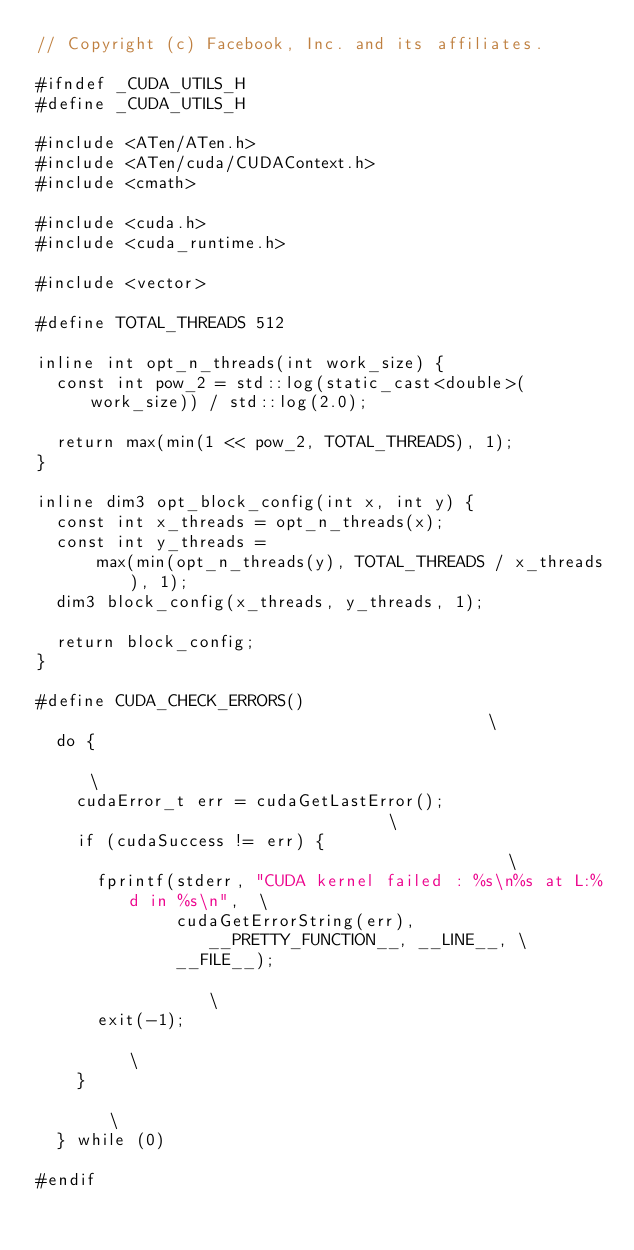<code> <loc_0><loc_0><loc_500><loc_500><_C_>// Copyright (c) Facebook, Inc. and its affiliates.

#ifndef _CUDA_UTILS_H
#define _CUDA_UTILS_H

#include <ATen/ATen.h>
#include <ATen/cuda/CUDAContext.h>
#include <cmath>

#include <cuda.h>
#include <cuda_runtime.h>

#include <vector>

#define TOTAL_THREADS 512

inline int opt_n_threads(int work_size) {
  const int pow_2 = std::log(static_cast<double>(work_size)) / std::log(2.0);

  return max(min(1 << pow_2, TOTAL_THREADS), 1);
}

inline dim3 opt_block_config(int x, int y) {
  const int x_threads = opt_n_threads(x);
  const int y_threads =
      max(min(opt_n_threads(y), TOTAL_THREADS / x_threads), 1);
  dim3 block_config(x_threads, y_threads, 1);

  return block_config;
}

#define CUDA_CHECK_ERRORS()                                           \
  do {                                                                \
    cudaError_t err = cudaGetLastError();                             \
    if (cudaSuccess != err) {                                         \
      fprintf(stderr, "CUDA kernel failed : %s\n%s at L:%d in %s\n",  \
              cudaGetErrorString(err), __PRETTY_FUNCTION__, __LINE__, \
              __FILE__);                                              \
      exit(-1);                                                       \
    }                                                                 \
  } while (0)

#endif
</code> 